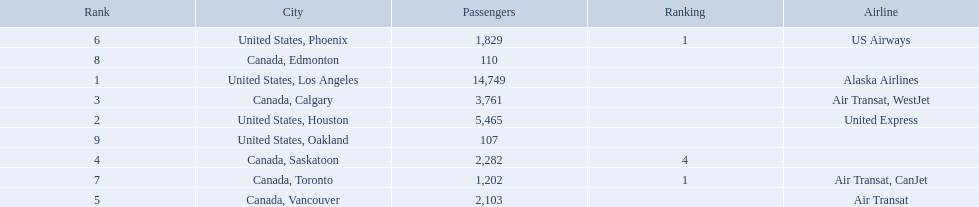What are the cities flown to? United States, Los Angeles, United States, Houston, Canada, Calgary, Canada, Saskatoon, Canada, Vancouver, United States, Phoenix, Canada, Toronto, Canada, Edmonton, United States, Oakland. What number of passengers did pheonix have? 1,829. 